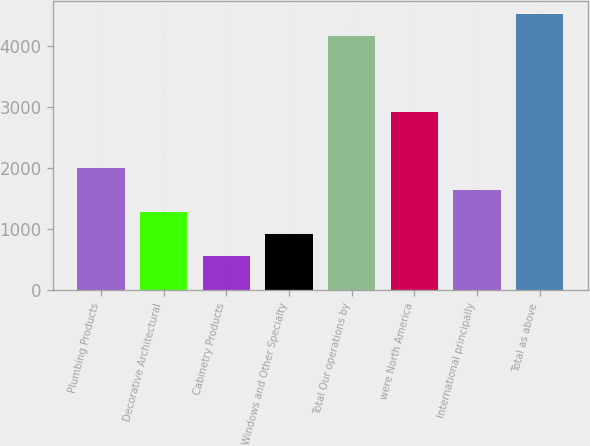<chart> <loc_0><loc_0><loc_500><loc_500><bar_chart><fcel>Plumbing Products<fcel>Decorative Architectural<fcel>Cabinetry Products<fcel>Windows and Other Specialty<fcel>Total Our operations by<fcel>were North America<fcel>International principally<fcel>Total as above<nl><fcel>2004.6<fcel>1285.8<fcel>567<fcel>926.4<fcel>4161<fcel>2925<fcel>1645.2<fcel>4520.4<nl></chart> 